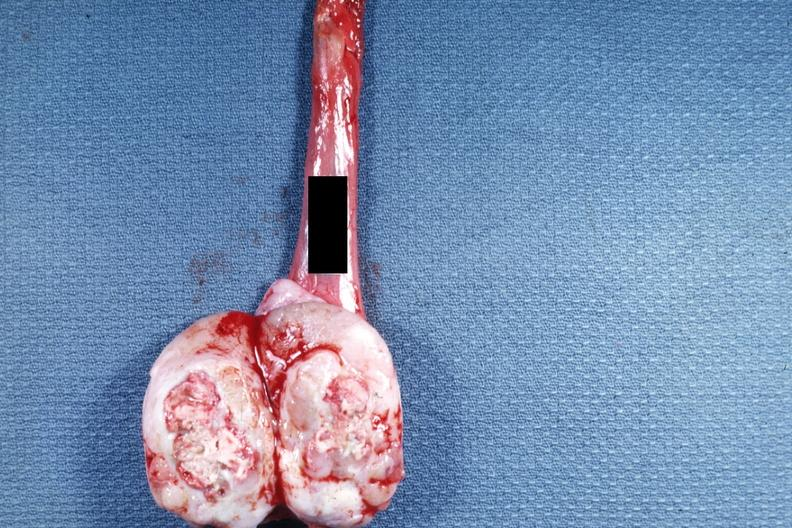how does this image show tumor mass?
Answer the question using a single word or phrase. With a large amount of necrosis 